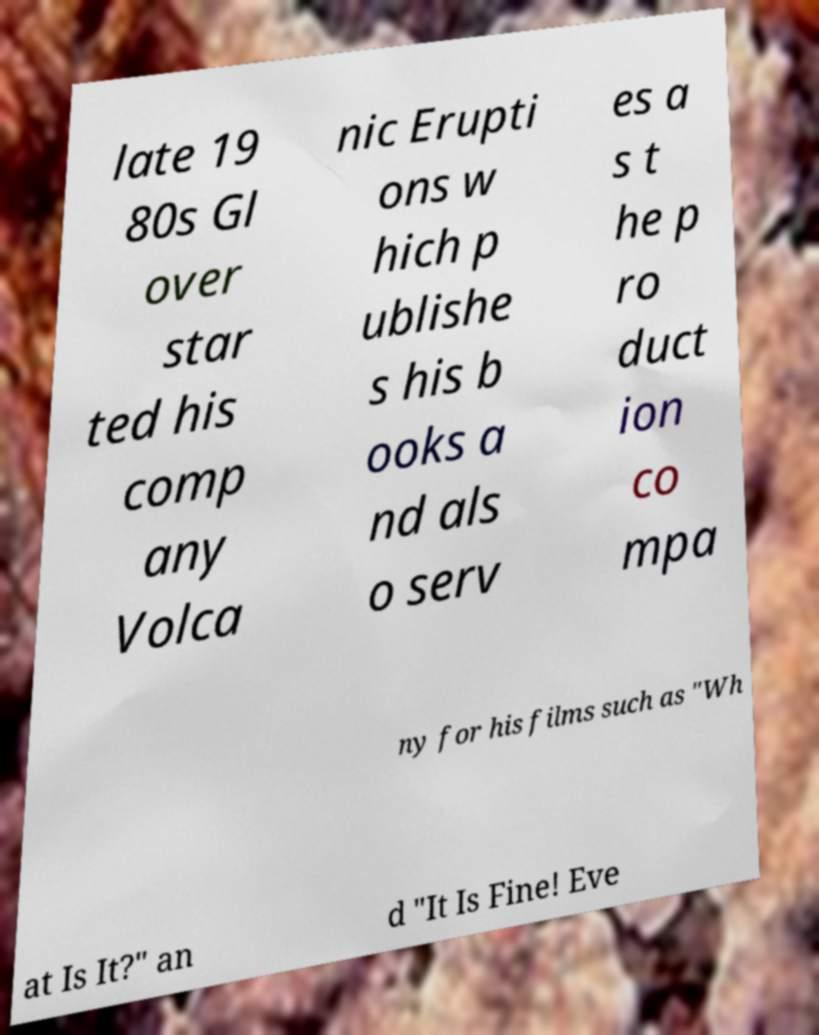There's text embedded in this image that I need extracted. Can you transcribe it verbatim? late 19 80s Gl over star ted his comp any Volca nic Erupti ons w hich p ublishe s his b ooks a nd als o serv es a s t he p ro duct ion co mpa ny for his films such as "Wh at Is It?" an d "It Is Fine! Eve 